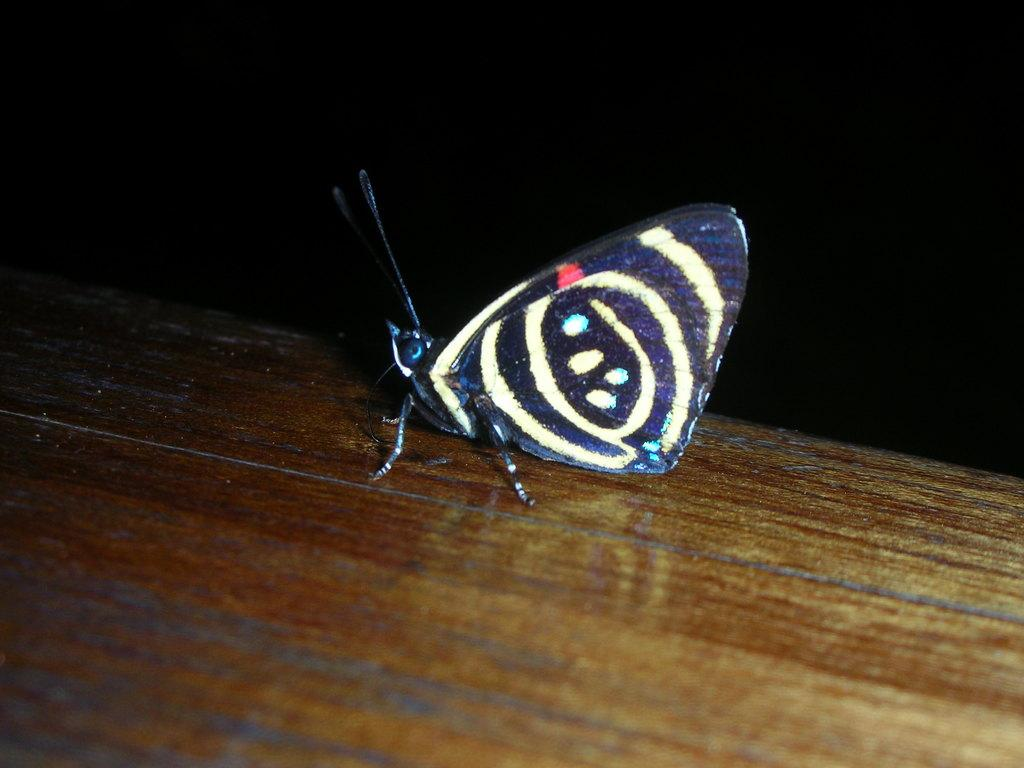What type of table is at the bottom of the image? There is a wooden table at the bottom of the image. What is on the wooden table? There is a butterfly on the wooden table. What can be seen in the background of the image? The background of the image is dark. What type of copy machine is visible in the image? There is no copy machine present in the image; it features a wooden table with a butterfly on it and a dark background. 